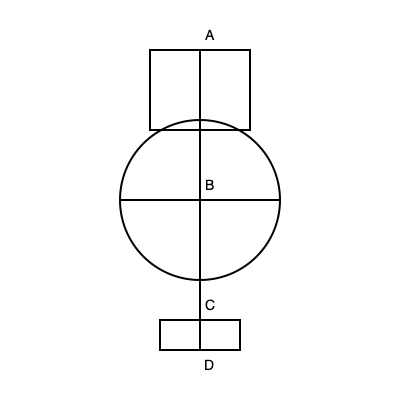In FLCL, Canti's design incorporates several distinct components. Referring to the technical drawing, which part of Canti's anatomy is represented by section B, and what is its primary function in relation to Naota's transformation? To answer this question, let's analyze Canti's anatomy as depicted in FLCL:

1. Section A represents Canti's head, which is shaped like a TV screen.
2. Section B is the central part of Canti's body, which is cylindrical in shape.
3. Section C represents Canti's legs.
4. Section D is the base or feet of Canti.

The key to this question lies in understanding Section B's role:

1. Section B is Canti's torso or main body cavity.
2. In FLCL, this section serves a crucial function related to Naota's transformation.
3. When Naota is absorbed into Canti, he enters through the TV screen (Section A) and is housed within Section B.
4. This absorption triggers Canti's transformation into the powerful "Atomsk" form.
5. Section B acts as a catalyst for Naota's N.O. channel, amplifying his latent powers.
6. This process allows Canti and Naota to merge, creating a symbiotic relationship that enhances their combined abilities.

Therefore, Section B's primary function is to serve as a containment and amplification chamber for Naota during their fusion, facilitating the transformation into the "Atomsk" form.
Answer: Torso; containment and amplification chamber for Naota's transformation 